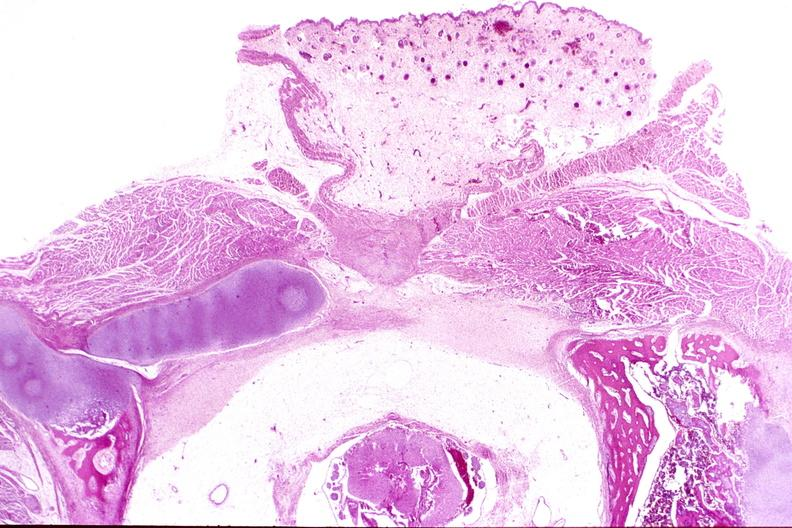does this image show neural tube defect, meningomyelocele?
Answer the question using a single word or phrase. Yes 